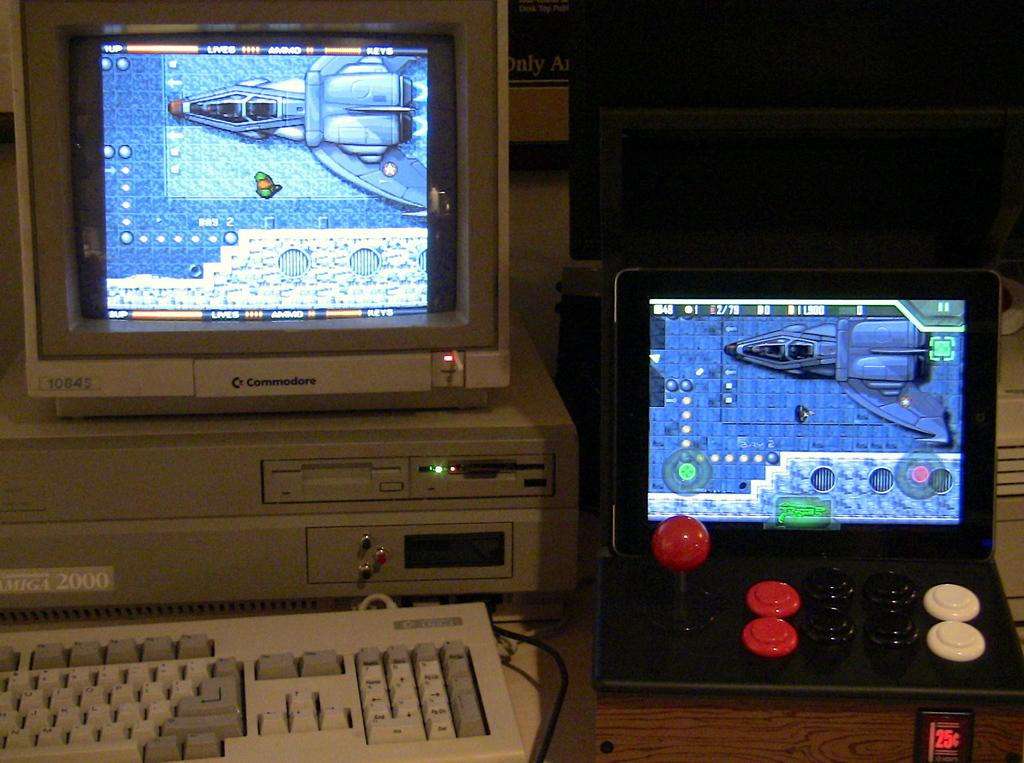<image>
Create a compact narrative representing the image presented. A Commodore computer is next to a smaller computer. 